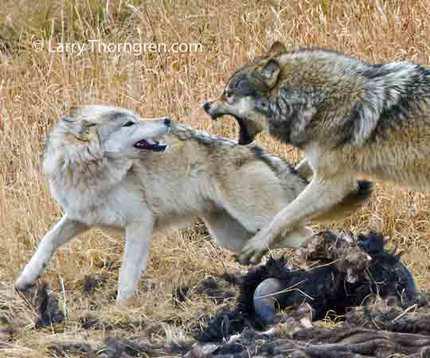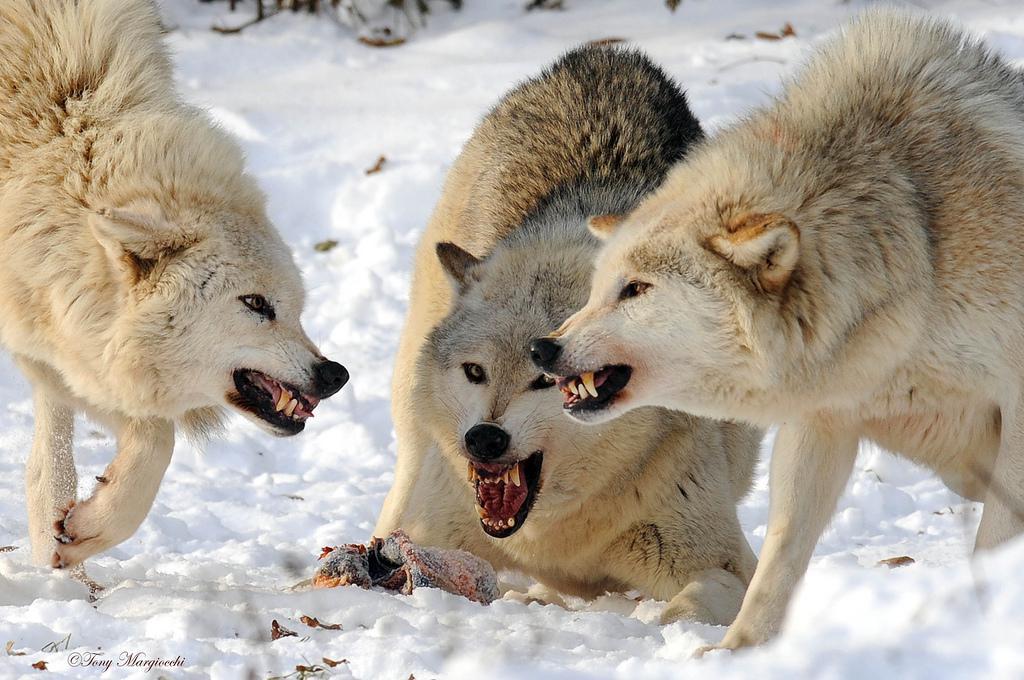The first image is the image on the left, the second image is the image on the right. Examine the images to the left and right. Is the description "In at least one image, there are three wolves on snow with at least one with an open angry mouth." accurate? Answer yes or no. Yes. The first image is the image on the left, the second image is the image on the right. Evaluate the accuracy of this statement regarding the images: "One image shows at least three wolves in a confrontational scene, with the one at the center baring its fangs with a wide open mouth, and the other image shows a wolf jumping on another wolf.". Is it true? Answer yes or no. Yes. 